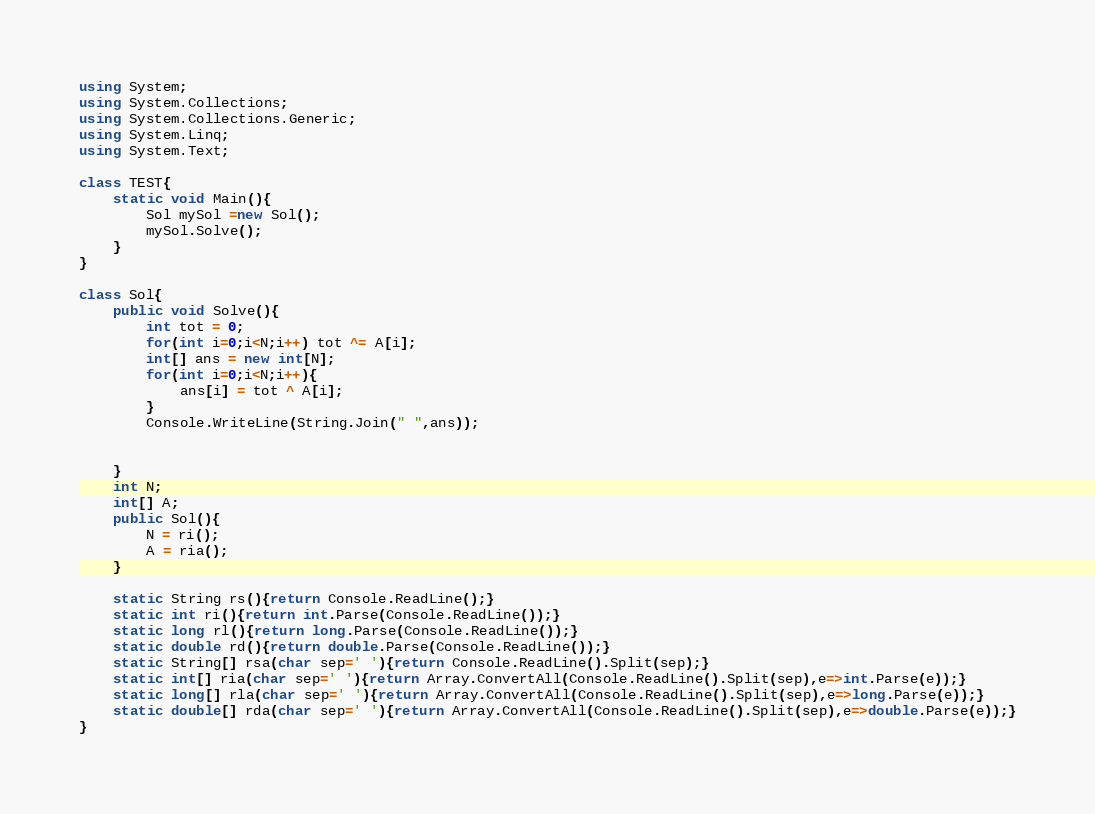<code> <loc_0><loc_0><loc_500><loc_500><_C#_>using System;
using System.Collections;
using System.Collections.Generic;
using System.Linq;
using System.Text;

class TEST{
	static void Main(){
		Sol mySol =new Sol();
		mySol.Solve();
	}
}

class Sol{
	public void Solve(){
		int tot = 0;
		for(int i=0;i<N;i++) tot ^= A[i];
		int[] ans = new int[N];
		for(int i=0;i<N;i++){
			ans[i] = tot ^ A[i];
		}
		Console.WriteLine(String.Join(" ",ans));
		
		
	}
	int N;
	int[] A;
	public Sol(){
		N = ri();
		A = ria();
	}

	static String rs(){return Console.ReadLine();}
	static int ri(){return int.Parse(Console.ReadLine());}
	static long rl(){return long.Parse(Console.ReadLine());}
	static double rd(){return double.Parse(Console.ReadLine());}
	static String[] rsa(char sep=' '){return Console.ReadLine().Split(sep);}
	static int[] ria(char sep=' '){return Array.ConvertAll(Console.ReadLine().Split(sep),e=>int.Parse(e));}
	static long[] rla(char sep=' '){return Array.ConvertAll(Console.ReadLine().Split(sep),e=>long.Parse(e));}
	static double[] rda(char sep=' '){return Array.ConvertAll(Console.ReadLine().Split(sep),e=>double.Parse(e));}
}
</code> 